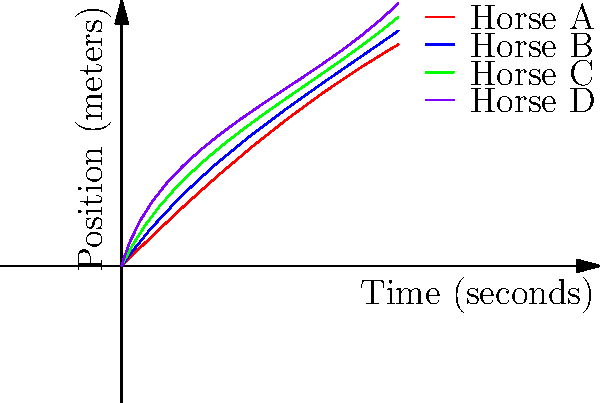In a high-stakes horse race, four horses are tracked on a 2D graph showing their positions over time. Based on the graph, which horse has the highest probability of winning, and what would be the most profitable bet considering the given odds: Horse A (3:1), Horse B (2:1), Horse C (4:1), and Horse D (5:1)? To determine the horse with the highest probability of winning and the most profitable bet, we need to analyze the graph and consider the given odds:

1. Analyze the graph:
   - Horse A (red): Starts strong but levels off
   - Horse B (blue): Consistent pace, slightly ahead at the end
   - Horse C (green): Starts slow but shows a strong finish
   - Horse D (purple): Maintains a steady pace but falls behind

2. Determine the likely winner:
   Based on the graph, Horse B appears to have the highest probability of winning as it maintains a consistent pace and is slightly ahead at the end.

3. Calculate the potential profit for each horse:
   Let's assume a $100 bet for each horse:
   - Horse A (3:1): Profit = $100 * 3 = $300
   - Horse B (2:1): Profit = $100 * 2 = $200
   - Horse C (4:1): Profit = $100 * 4 = $400
   - Horse D (5:1): Profit = $100 * 5 = $500

4. Consider the risk-reward ratio:
   Horse B has the highest probability of winning but offers the lowest payout. Horse C shows a strong finish and has better odds than Horse B.

5. Determine the most profitable bet:
   Considering both the probability of winning and the potential payout, Horse C offers the best balance of risk and reward. It has a good chance of winning based on its strong finish and offers a higher payout (4:1) compared to the favorite, Horse B (2:1).
Answer: Horse B has the highest probability of winning. The most profitable bet is on Horse C (4:1 odds). 